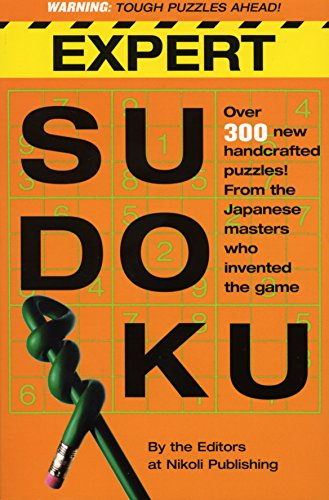What is the genre of this book? While the initial response misidentified the genre, the correct category for 'Expert Sudoku' would be 'Games & Puzzles,' as it involves logic-based number placement puzzles. 